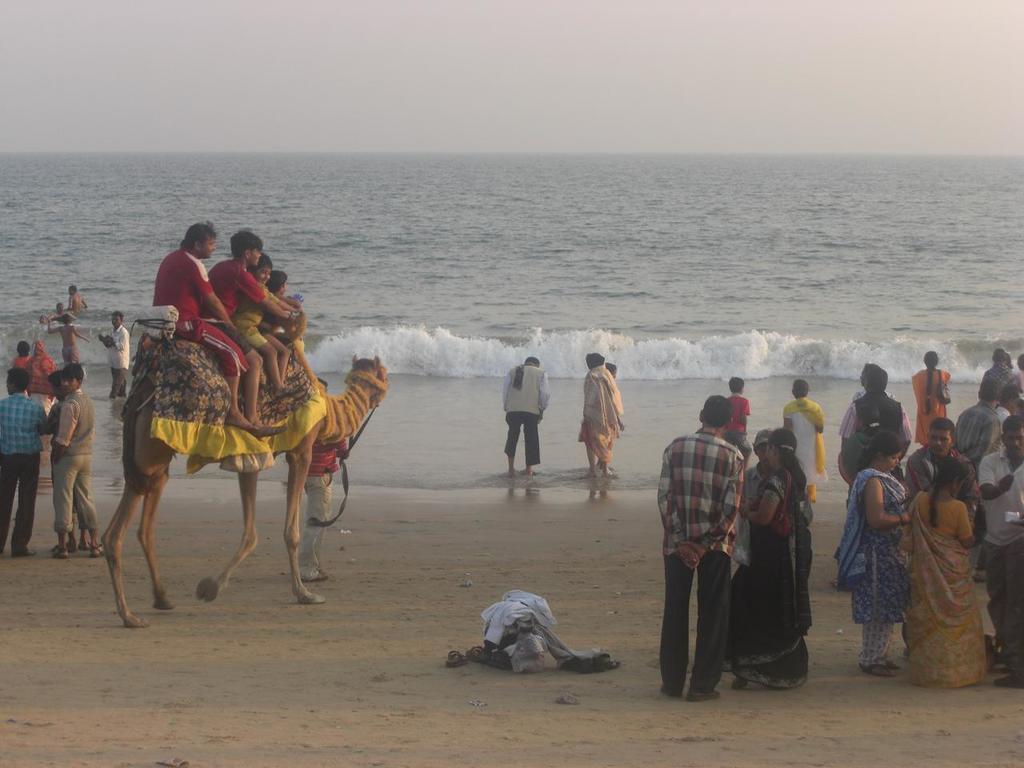Describe this image in one or two sentences. In the image there are few people standing. And also there a camel. On the camel there are few people sitting. There is water with waves. At the top of the image there is sky. 